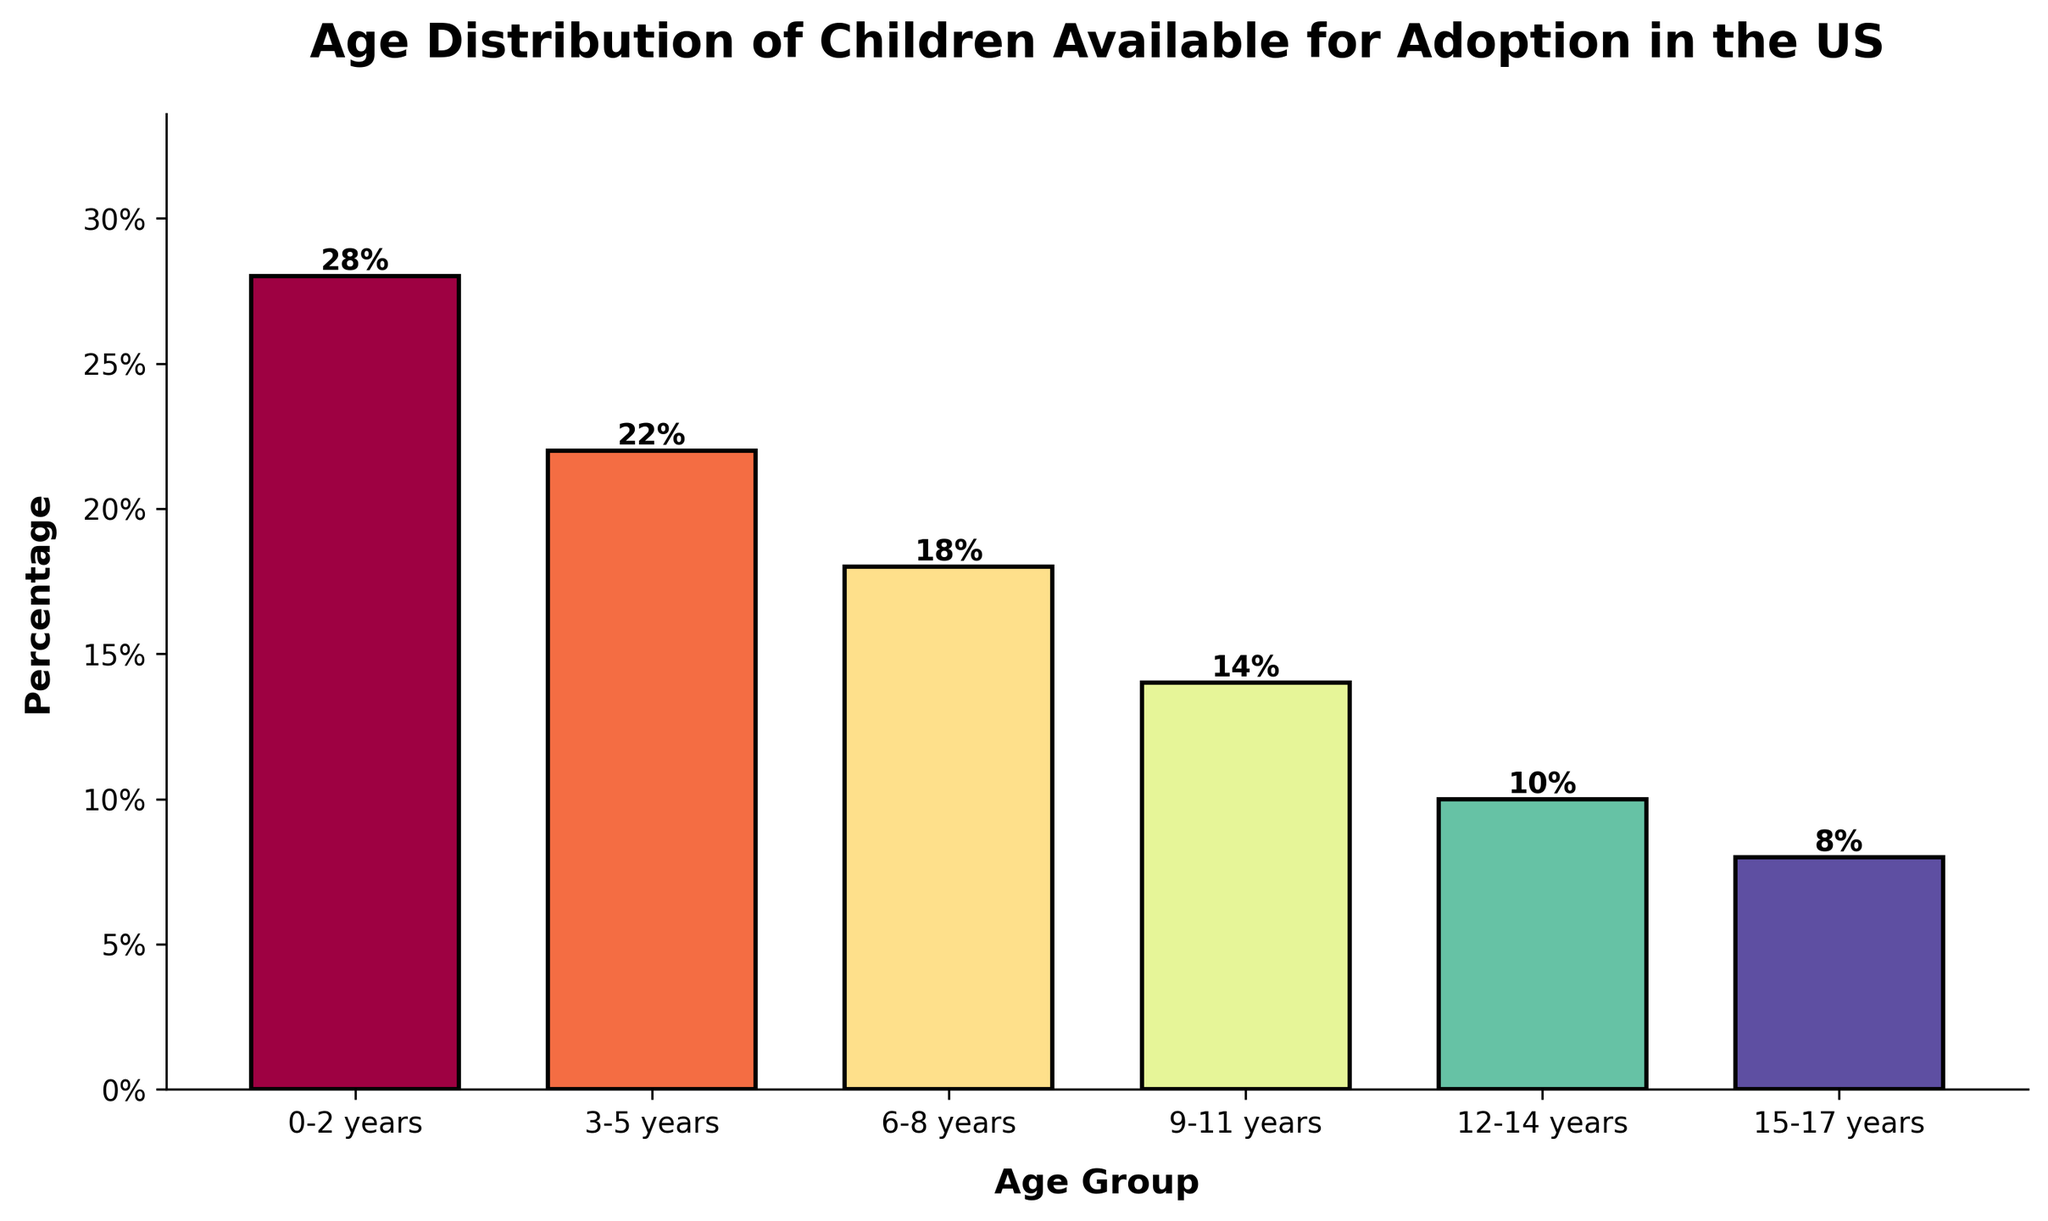Which age group has the highest percentage of children available for adoption? The bar for the "0-2 years" age group is the tallest among all the bars in the chart and its value is 28%.
Answer: 0-2 years Which age group has the lowest percentage of children available for adoption? The bar for the "15-17 years" age group is the shortest among all the bars in the chart and its value is 8%.
Answer: 15-17 years What is the total percentage of children available for adoption in the age groups 3-5 years and 6-8 years combined? The percentage for "3-5 years" is 22% and for "6-8 years" is 18%. Adding these together: 22% + 18% = 40%.
Answer: 40% How much higher is the percentage of children available for adoption in the age group 0-2 years compared to the age group 12-14 years? The percentage for "0-2 years" is 28% and for "12-14 years" is 10%. Subtracting these: 28% - 10% = 18%.
Answer: 18% Among the age groups 6-8 years and 9-11 years, which one has a higher percentage and by how much? The percentage for "6-8 years" is 18% and for "9-11 years" is 14%. Subtracting these: 18% - 14% = 4%.
Answer: 6-8 years by 4% What is the average percentage of children available for adoption across all age groups? Adding up the percentages: 28% + 22% + 18% + 14% + 10% + 8% = 100%. There are 6 age groups, so the average is 100% / 6 = 16.67%.
Answer: 16.67% Is the percentage of children available for adoption in the 9-11 years age group greater or less than half of the percentage in the 0-2 years age group? The percentage for "0-2 years" is 28%. Half of this is 28% / 2 = 14%. The percentage for "9-11 years" is 14%, which is equal to half of 28%.
Answer: Equal What is the difference in percentage between the age groups 3-5 years and 9-11 years? The percentage for "3-5 years" is 22% and for "9-11 years" is 14%. Subtracting these: 22% - 14% = 8%.
Answer: 8% What's the combined percentage of children available for adoption in the age groups 6-8 years, 9-11 years, and 12-14 years? Adding the percentages for "6-8 years" (18%), "9-11 years" (14%), and "12-14 years" (10%): 18% + 14% + 10% = 42%.
Answer: 42% Which age group has a percentage that is double the percentage of the 12-14 years age group? The percentage for "12-14 years" is 10%. Double this is 10% * 2 = 20%. The only age group close to this value is "3-5 years" with 22%, which is slightly more but approximately double.
Answer: 3-5 years 